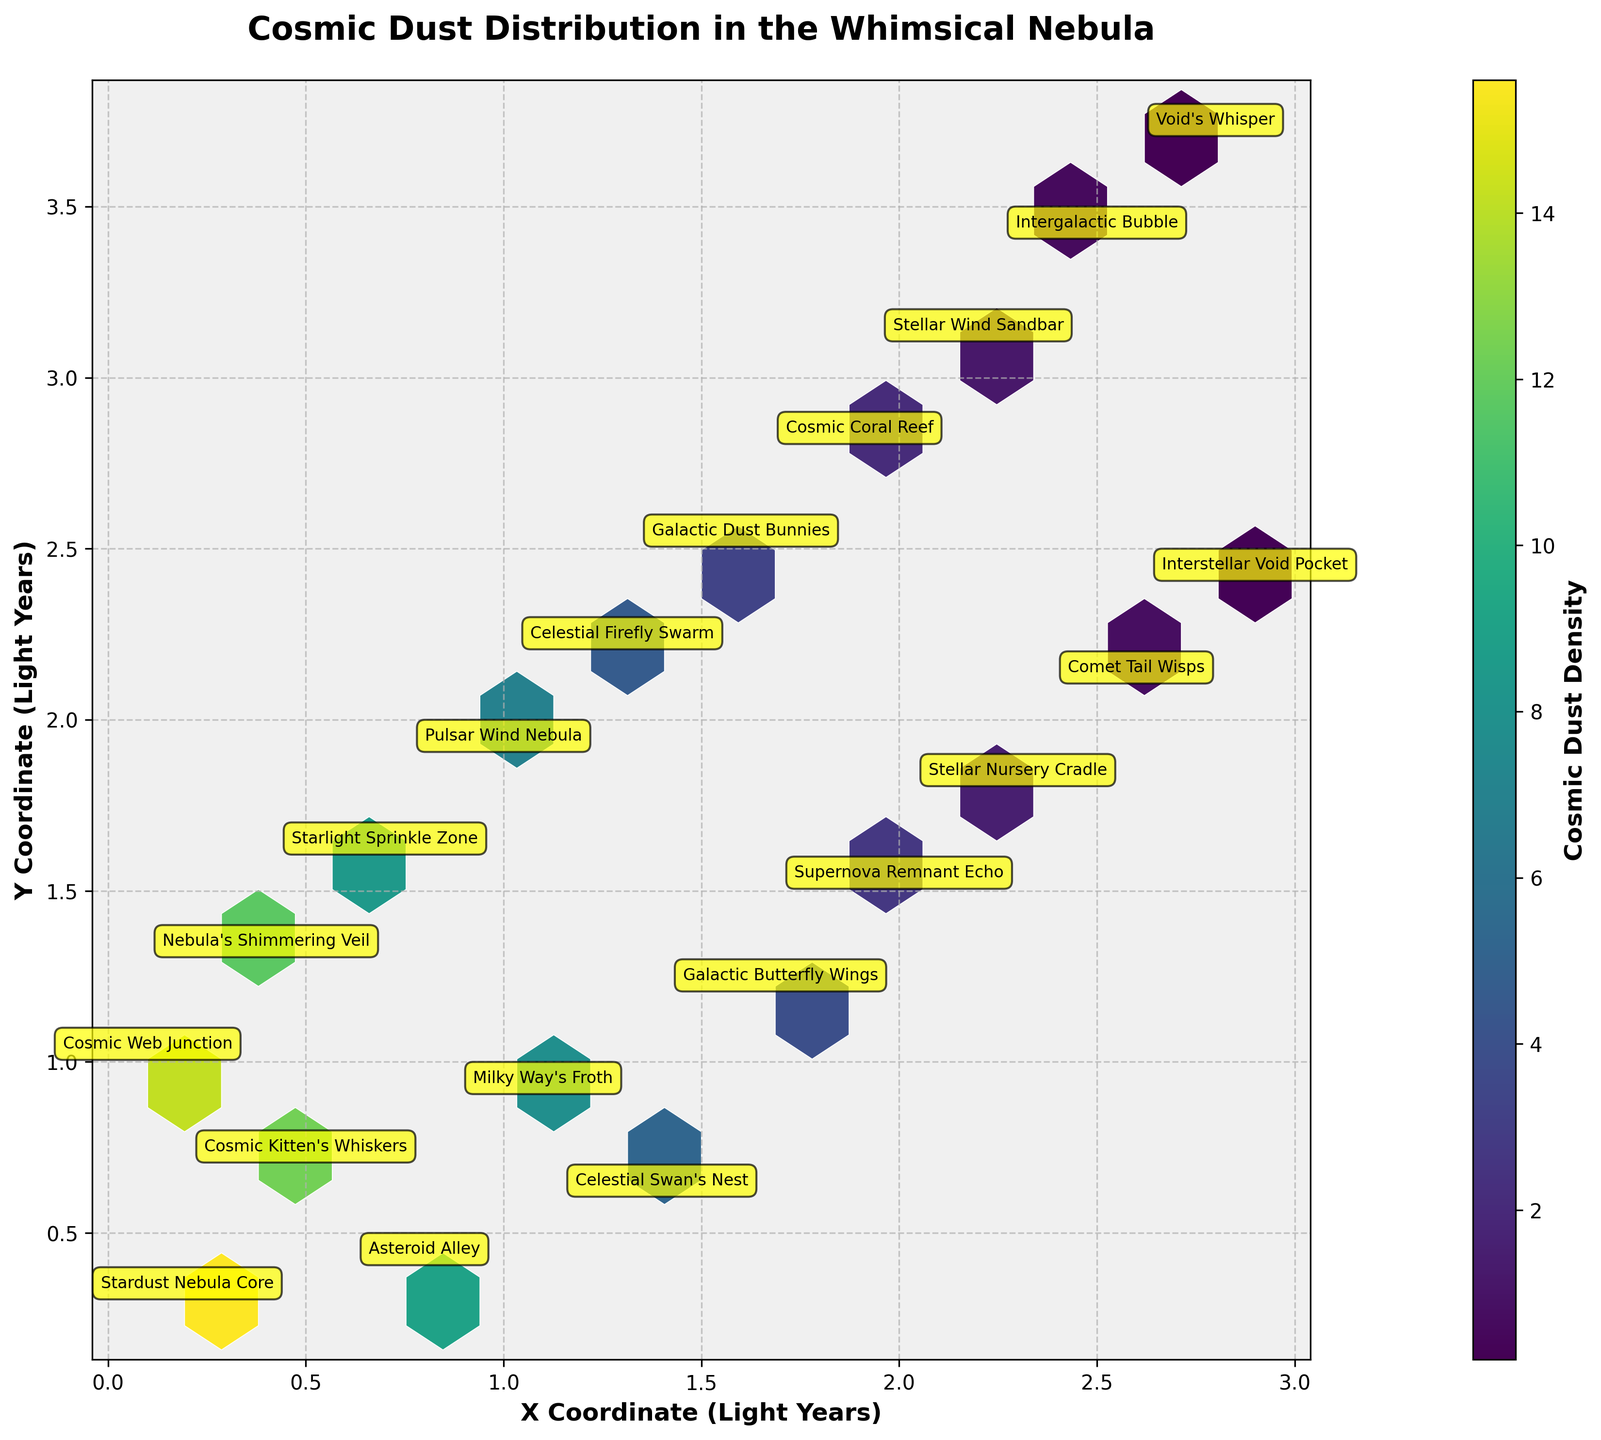What's the title of the hexbin plot? The title of the hexbin plot is located at the top center of the figure.
Answer: Cosmic Dust Distribution in the Whimsical Nebula Which region of the nebula has the highest density of cosmic dust particles? To determine which region has the highest density, you can look for the darkest or most vibrant hexagon in the plot (representing the highest values on the colorbar). The highest density is 15.6 in the "Stardust Nebula Core".
Answer: Stardust Nebula Core What are the coordinates for the "Stellar Nursery Cradle"? The coordinates can be located based on the annotated points on the plot.
Answer: (2.3, 1.8) Between "Pulsar Wind Nebula" and "Nebula's Shimmering Veil", which region has a lower cosmic dust density? Compare the density values in the colorbar annotations for both regions: "Pulsar Wind Nebula" has a density of 6.9, whereas "Nebula's Shimmering Veil" has a density of 11.7.
Answer: Pulsar Wind Nebula How does the density of cosmic dust change as the coordinates increase from (0.1, 1.0) to (2.9, 2.4)? Observe that as the coordinates increase, the density generally decreases from 14.2 (Cosmic Web Junction) to 0.3 (Interstellar Void Pocket).
Answer: Generally decreases What is the average density of cosmic dust in "Stardust Nebula Core" and "Cosmic Web Junction"? Sum the densities of both regions (15.6 + 14.2) and divide by 2 to find the average.
Answer: 14.9 Comparing "Starlight Sprinkle Zone" and "Stellar Wind Sandbar", which has a higher density? Find the density values from the annotations: "Starlight Sprinkle Zone" has 8.5, and "Stellar Wind Sandbar" has 1.2.
Answer: Starlight Sprinkle Zone How many regions have a density of cosmic dust greater than 10? Count the number of annotations with densities above 10: "Stardust Nebula Core", "Cosmic Kitten's Whiskers", "Cosmic Web Junction", "Nebula's Shimmering Veil".
Answer: Four Identify the region closest to the coordinates (1.5, 1.5). Approximate the annotations on the plot and compare coordinates. Closest region is "Galactic Butterfly Wings" at (1.7, 1.2).
Answer: Galactic Butterfly Wings Which color on the plot represents the highest cosmic dust density areas? Referring to the colorbar, the darkest or most saturated color (typically the deepest hue in a 'viridis' colormap) indicates the highest density areas.
Answer: Darkest/Vibrant Color 